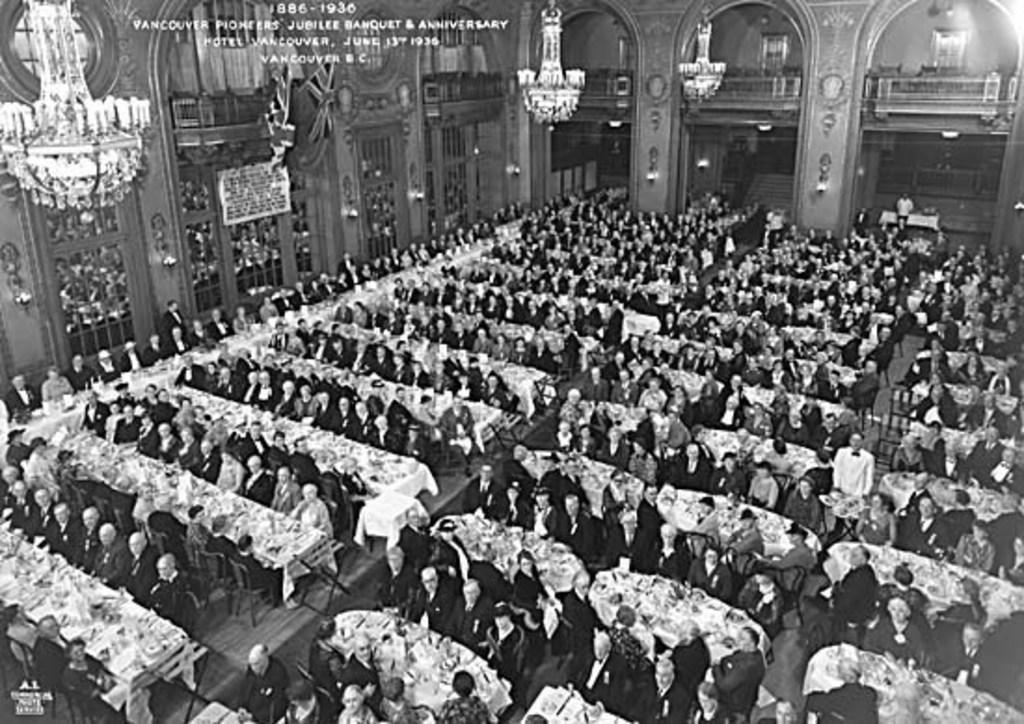How would you summarize this image in a sentence or two? There are people those who are sitting around the tables in the center of the image and there are chandeliers and arches at the top side. There are lamps and text in the image. 